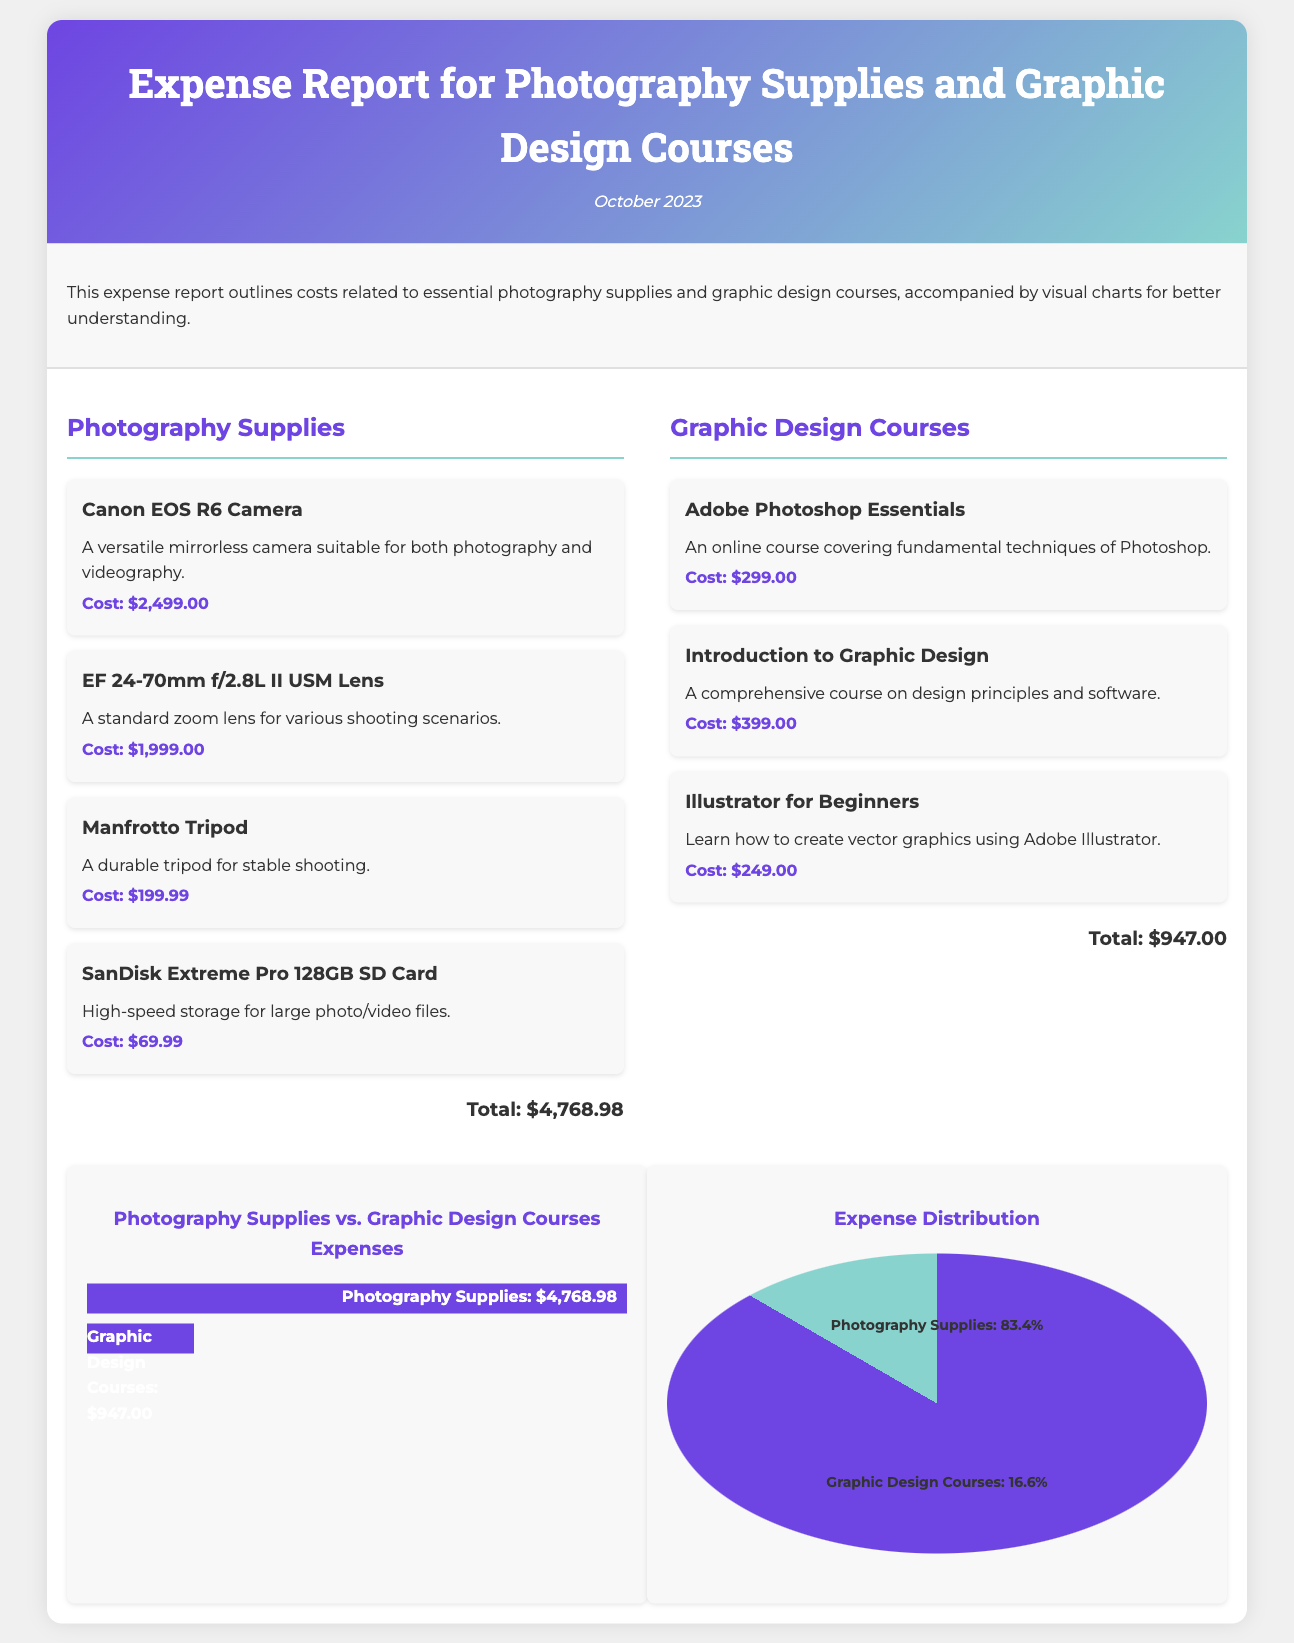What is the total cost for Photography Supplies? The total cost for Photography Supplies is listed at the end of the section, which adds up all items in that category.
Answer: $4,768.98 What course covers fundamental techniques of Photoshop? The document mentions a specific course that focuses on Photoshop techniques under the Graphic Design Courses section.
Answer: Adobe Photoshop Essentials What is the cost of the Manfrotto Tripod? The cost for the Manfrotto Tripod is detailed in the Photography Supplies section.
Answer: $199.99 What percentage of expenses is attributed to Graphic Design Courses? The pie chart shows the distribution of expenses, indicating the percentage for Graphic Design Courses.
Answer: 16.6% Which item has the highest cost in the Photography Supplies category? The item with the highest cost can be found by evaluating the costs listed in that section.
Answer: Canon EOS R6 Camera What is the total expense on Graphic Design Courses? The total expense for Graphic Design Courses is summarized at the end of that section.
Answer: $947.00 How many photography items are listed in the report? The report lists all the items under the Photography Supplies section, which can be counted.
Answer: 4 Which course is designed for beginners to learn vector graphics? The document specifies which course is focused on beginners in vector graphics within the Graphic Design Courses section.
Answer: Illustrator for Beginners What is the date mentioned in the report? The date is indicated at the top of the document, providing context for the expenses being reported.
Answer: October 2023 